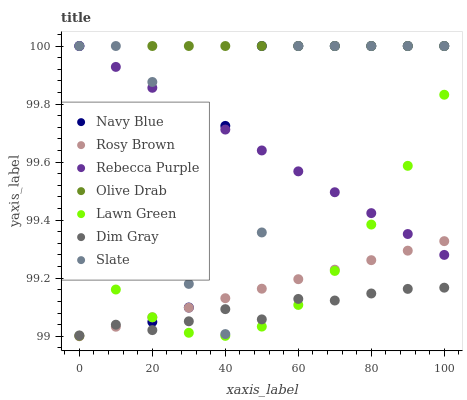Does Dim Gray have the minimum area under the curve?
Answer yes or no. Yes. Does Olive Drab have the maximum area under the curve?
Answer yes or no. Yes. Does Navy Blue have the minimum area under the curve?
Answer yes or no. No. Does Navy Blue have the maximum area under the curve?
Answer yes or no. No. Is Rebecca Purple the smoothest?
Answer yes or no. Yes. Is Slate the roughest?
Answer yes or no. Yes. Is Dim Gray the smoothest?
Answer yes or no. No. Is Dim Gray the roughest?
Answer yes or no. No. Does Rosy Brown have the lowest value?
Answer yes or no. Yes. Does Dim Gray have the lowest value?
Answer yes or no. No. Does Olive Drab have the highest value?
Answer yes or no. Yes. Does Dim Gray have the highest value?
Answer yes or no. No. Is Dim Gray less than Navy Blue?
Answer yes or no. Yes. Is Navy Blue greater than Dim Gray?
Answer yes or no. Yes. Does Rebecca Purple intersect Olive Drab?
Answer yes or no. Yes. Is Rebecca Purple less than Olive Drab?
Answer yes or no. No. Is Rebecca Purple greater than Olive Drab?
Answer yes or no. No. Does Dim Gray intersect Navy Blue?
Answer yes or no. No. 